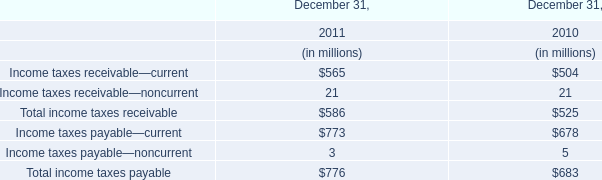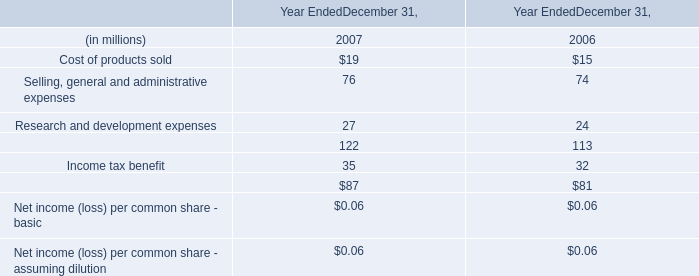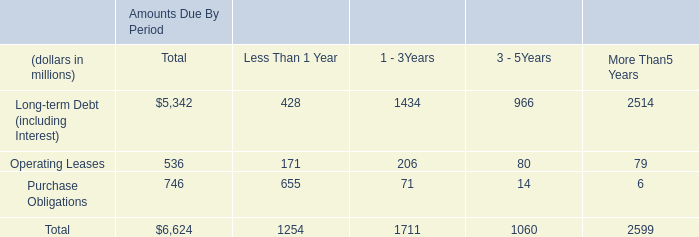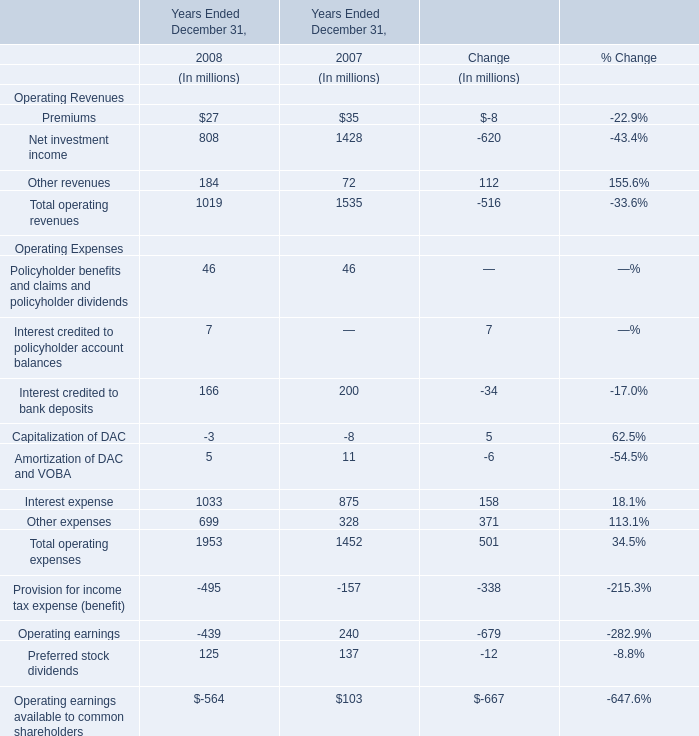What is the average value of Interest expense in Table 3 and Income tax benefit in Table 1 in 2007? (in million) 
Computations: ((875 + 35) / 2)
Answer: 455.0. 